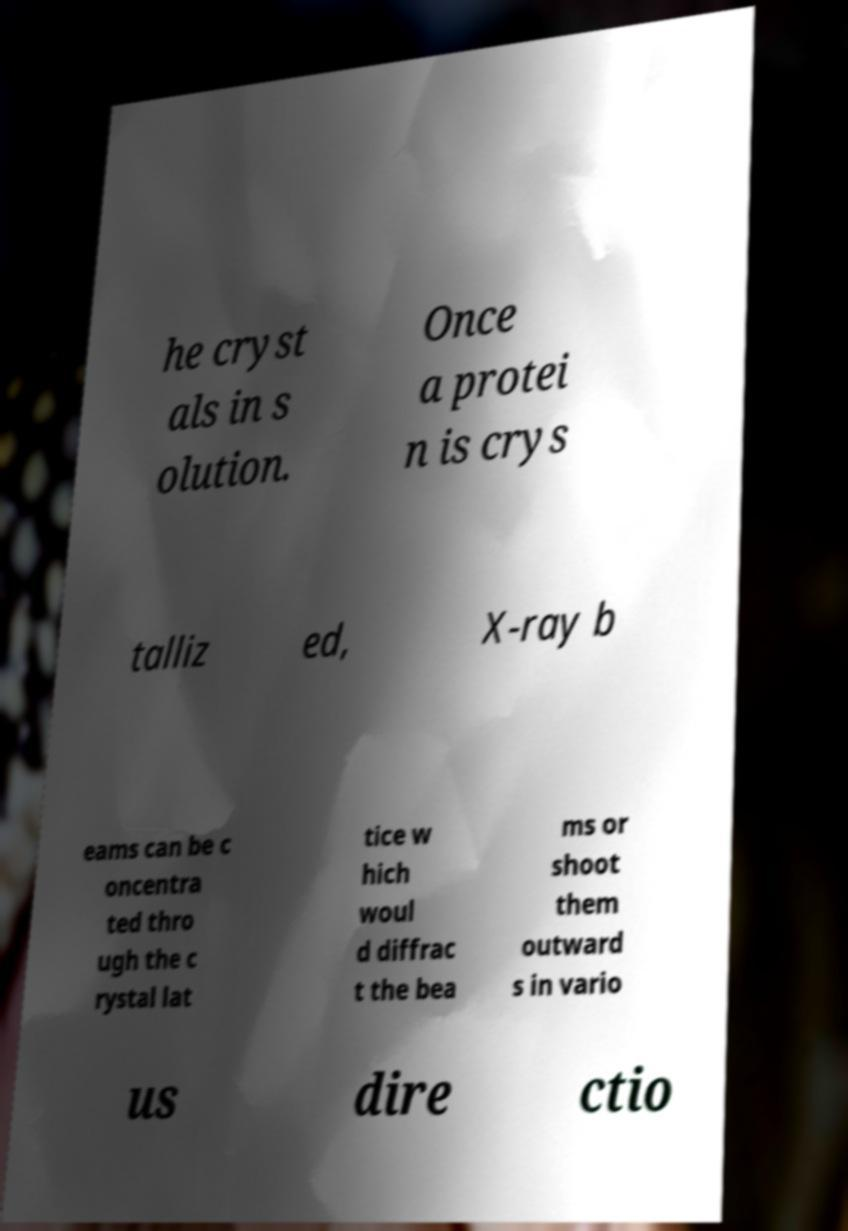Could you extract and type out the text from this image? he cryst als in s olution. Once a protei n is crys talliz ed, X-ray b eams can be c oncentra ted thro ugh the c rystal lat tice w hich woul d diffrac t the bea ms or shoot them outward s in vario us dire ctio 